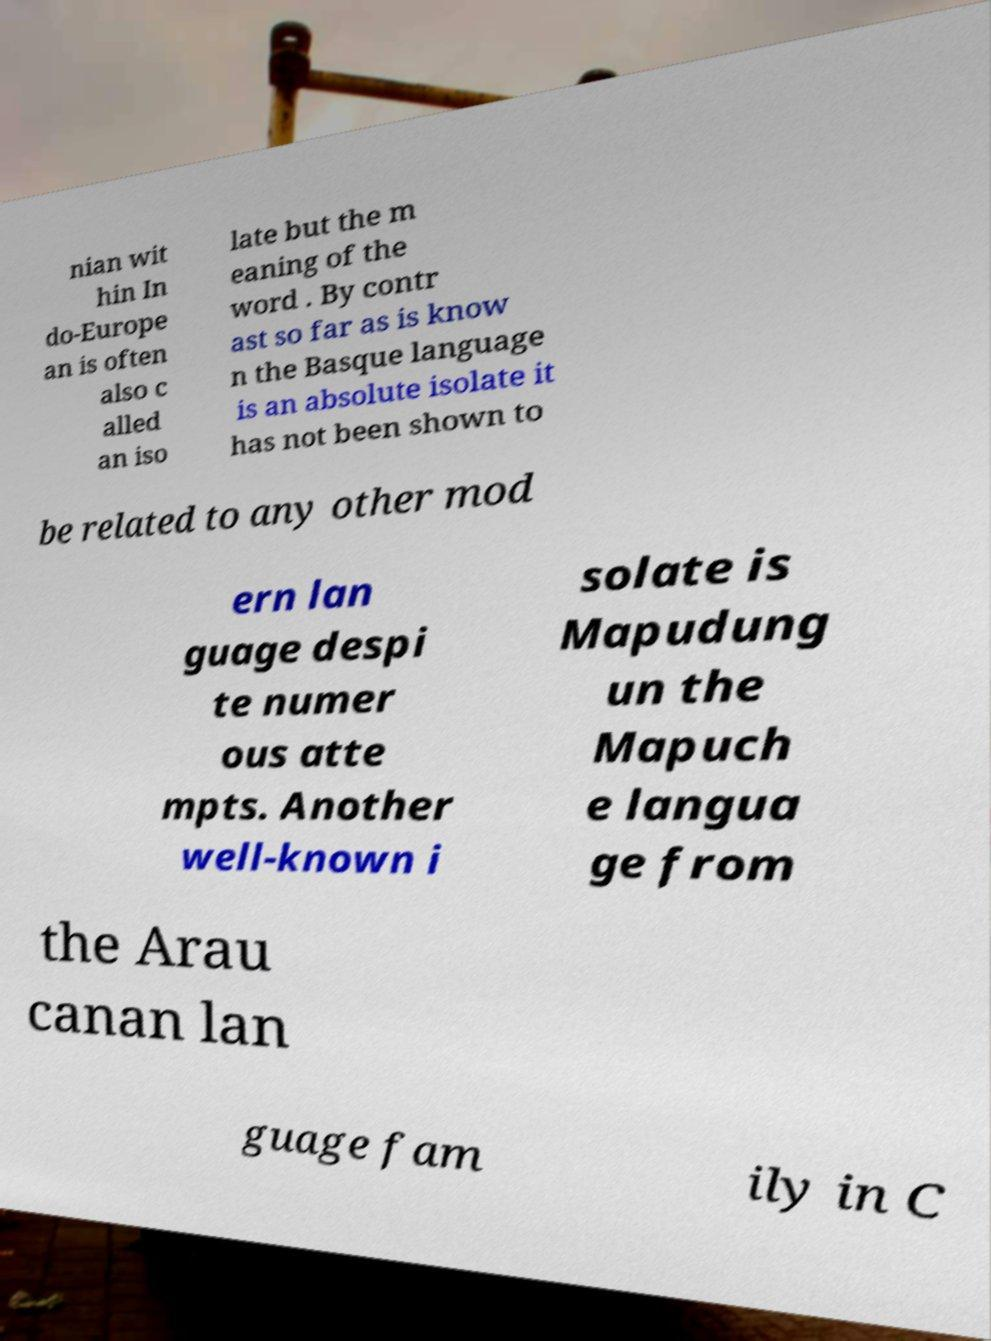Could you assist in decoding the text presented in this image and type it out clearly? nian wit hin In do-Europe an is often also c alled an iso late but the m eaning of the word . By contr ast so far as is know n the Basque language is an absolute isolate it has not been shown to be related to any other mod ern lan guage despi te numer ous atte mpts. Another well-known i solate is Mapudung un the Mapuch e langua ge from the Arau canan lan guage fam ily in C 